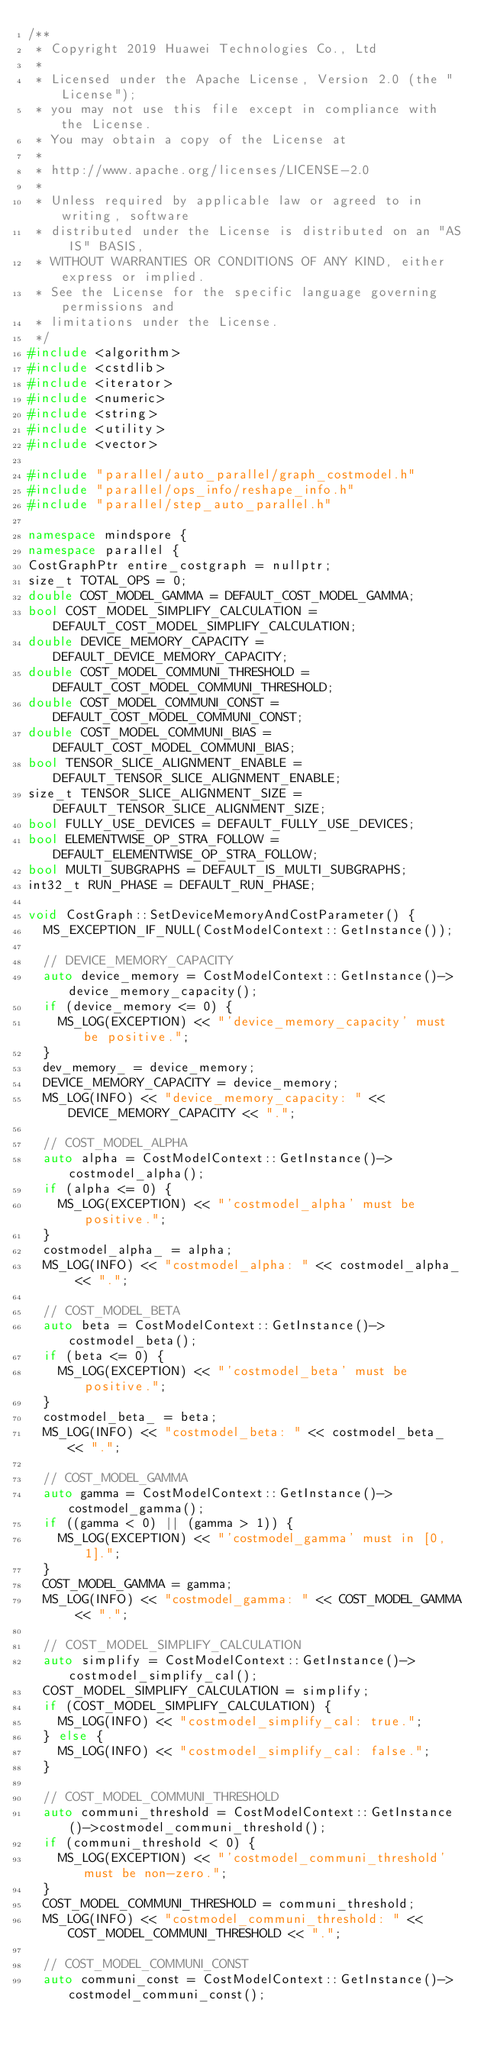Convert code to text. <code><loc_0><loc_0><loc_500><loc_500><_C++_>/**
 * Copyright 2019 Huawei Technologies Co., Ltd
 *
 * Licensed under the Apache License, Version 2.0 (the "License");
 * you may not use this file except in compliance with the License.
 * You may obtain a copy of the License at
 *
 * http://www.apache.org/licenses/LICENSE-2.0
 *
 * Unless required by applicable law or agreed to in writing, software
 * distributed under the License is distributed on an "AS IS" BASIS,
 * WITHOUT WARRANTIES OR CONDITIONS OF ANY KIND, either express or implied.
 * See the License for the specific language governing permissions and
 * limitations under the License.
 */
#include <algorithm>
#include <cstdlib>
#include <iterator>
#include <numeric>
#include <string>
#include <utility>
#include <vector>

#include "parallel/auto_parallel/graph_costmodel.h"
#include "parallel/ops_info/reshape_info.h"
#include "parallel/step_auto_parallel.h"

namespace mindspore {
namespace parallel {
CostGraphPtr entire_costgraph = nullptr;
size_t TOTAL_OPS = 0;
double COST_MODEL_GAMMA = DEFAULT_COST_MODEL_GAMMA;
bool COST_MODEL_SIMPLIFY_CALCULATION = DEFAULT_COST_MODEL_SIMPLIFY_CALCULATION;
double DEVICE_MEMORY_CAPACITY = DEFAULT_DEVICE_MEMORY_CAPACITY;
double COST_MODEL_COMMUNI_THRESHOLD = DEFAULT_COST_MODEL_COMMUNI_THRESHOLD;
double COST_MODEL_COMMUNI_CONST = DEFAULT_COST_MODEL_COMMUNI_CONST;
double COST_MODEL_COMMUNI_BIAS = DEFAULT_COST_MODEL_COMMUNI_BIAS;
bool TENSOR_SLICE_ALIGNMENT_ENABLE = DEFAULT_TENSOR_SLICE_ALIGNMENT_ENABLE;
size_t TENSOR_SLICE_ALIGNMENT_SIZE = DEFAULT_TENSOR_SLICE_ALIGNMENT_SIZE;
bool FULLY_USE_DEVICES = DEFAULT_FULLY_USE_DEVICES;
bool ELEMENTWISE_OP_STRA_FOLLOW = DEFAULT_ELEMENTWISE_OP_STRA_FOLLOW;
bool MULTI_SUBGRAPHS = DEFAULT_IS_MULTI_SUBGRAPHS;
int32_t RUN_PHASE = DEFAULT_RUN_PHASE;

void CostGraph::SetDeviceMemoryAndCostParameter() {
  MS_EXCEPTION_IF_NULL(CostModelContext::GetInstance());

  // DEVICE_MEMORY_CAPACITY
  auto device_memory = CostModelContext::GetInstance()->device_memory_capacity();
  if (device_memory <= 0) {
    MS_LOG(EXCEPTION) << "'device_memory_capacity' must be positive.";
  }
  dev_memory_ = device_memory;
  DEVICE_MEMORY_CAPACITY = device_memory;
  MS_LOG(INFO) << "device_memory_capacity: " << DEVICE_MEMORY_CAPACITY << ".";

  // COST_MODEL_ALPHA
  auto alpha = CostModelContext::GetInstance()->costmodel_alpha();
  if (alpha <= 0) {
    MS_LOG(EXCEPTION) << "'costmodel_alpha' must be positive.";
  }
  costmodel_alpha_ = alpha;
  MS_LOG(INFO) << "costmodel_alpha: " << costmodel_alpha_ << ".";

  // COST_MODEL_BETA
  auto beta = CostModelContext::GetInstance()->costmodel_beta();
  if (beta <= 0) {
    MS_LOG(EXCEPTION) << "'costmodel_beta' must be positive.";
  }
  costmodel_beta_ = beta;
  MS_LOG(INFO) << "costmodel_beta: " << costmodel_beta_ << ".";

  // COST_MODEL_GAMMA
  auto gamma = CostModelContext::GetInstance()->costmodel_gamma();
  if ((gamma < 0) || (gamma > 1)) {
    MS_LOG(EXCEPTION) << "'costmodel_gamma' must in [0, 1].";
  }
  COST_MODEL_GAMMA = gamma;
  MS_LOG(INFO) << "costmodel_gamma: " << COST_MODEL_GAMMA << ".";

  // COST_MODEL_SIMPLIFY_CALCULATION
  auto simplify = CostModelContext::GetInstance()->costmodel_simplify_cal();
  COST_MODEL_SIMPLIFY_CALCULATION = simplify;
  if (COST_MODEL_SIMPLIFY_CALCULATION) {
    MS_LOG(INFO) << "costmodel_simplify_cal: true.";
  } else {
    MS_LOG(INFO) << "costmodel_simplify_cal: false.";
  }

  // COST_MODEL_COMMUNI_THRESHOLD
  auto communi_threshold = CostModelContext::GetInstance()->costmodel_communi_threshold();
  if (communi_threshold < 0) {
    MS_LOG(EXCEPTION) << "'costmodel_communi_threshold' must be non-zero.";
  }
  COST_MODEL_COMMUNI_THRESHOLD = communi_threshold;
  MS_LOG(INFO) << "costmodel_communi_threshold: " << COST_MODEL_COMMUNI_THRESHOLD << ".";

  // COST_MODEL_COMMUNI_CONST
  auto communi_const = CostModelContext::GetInstance()->costmodel_communi_const();</code> 